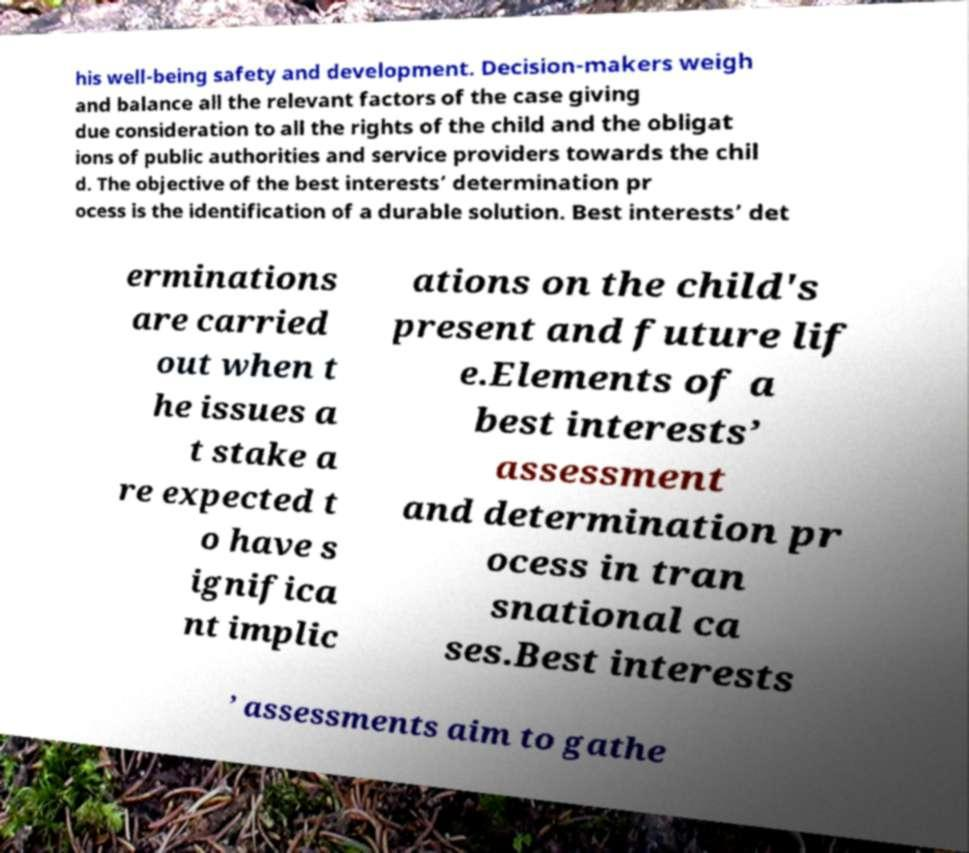Please identify and transcribe the text found in this image. his well-being safety and development. Decision-makers weigh and balance all the relevant factors of the case giving due consideration to all the rights of the child and the obligat ions of public authorities and service providers towards the chil d. The objective of the best interests’ determination pr ocess is the identification of a durable solution. Best interests’ det erminations are carried out when t he issues a t stake a re expected t o have s ignifica nt implic ations on the child's present and future lif e.Elements of a best interests’ assessment and determination pr ocess in tran snational ca ses.Best interests ’ assessments aim to gathe 